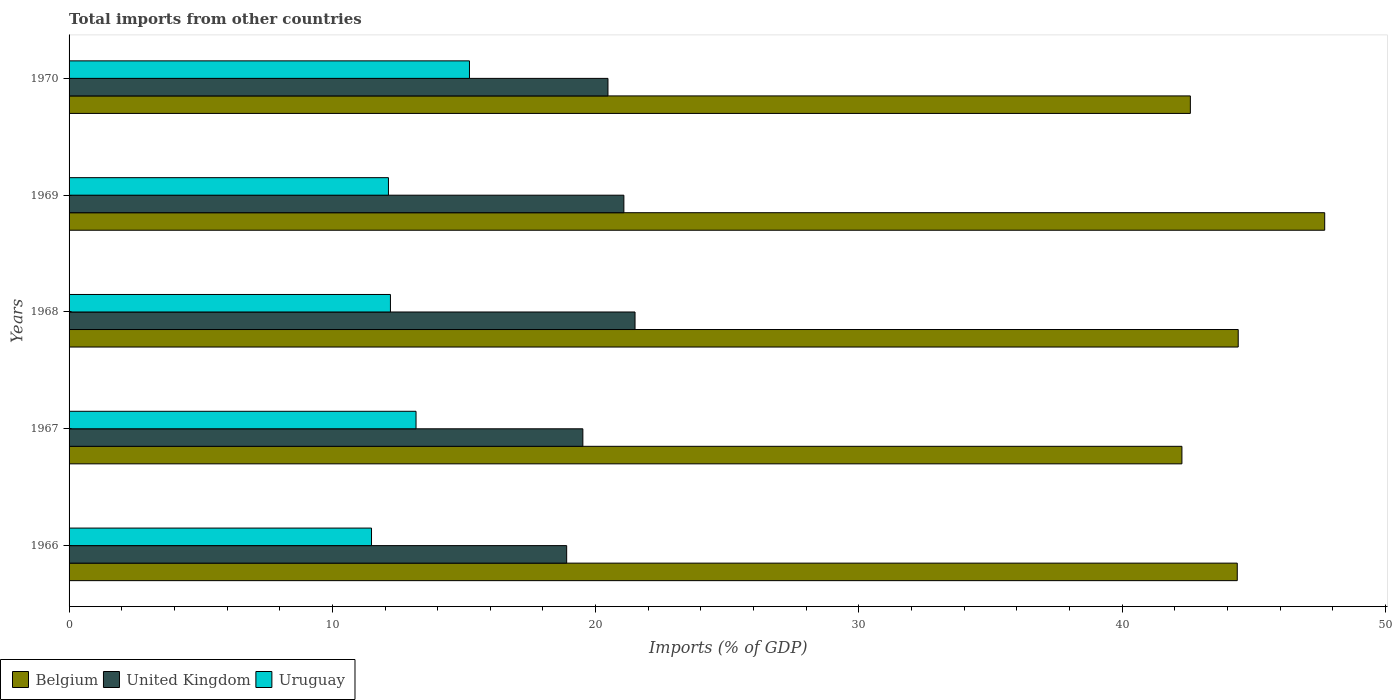How many different coloured bars are there?
Ensure brevity in your answer.  3. How many bars are there on the 2nd tick from the top?
Provide a succinct answer. 3. How many bars are there on the 5th tick from the bottom?
Your answer should be compact. 3. What is the label of the 5th group of bars from the top?
Offer a terse response. 1966. What is the total imports in United Kingdom in 1966?
Ensure brevity in your answer.  18.9. Across all years, what is the maximum total imports in Uruguay?
Offer a very short reply. 15.21. Across all years, what is the minimum total imports in Uruguay?
Your answer should be compact. 11.49. In which year was the total imports in Belgium maximum?
Offer a very short reply. 1969. In which year was the total imports in United Kingdom minimum?
Offer a very short reply. 1966. What is the total total imports in United Kingdom in the graph?
Keep it short and to the point. 101.45. What is the difference between the total imports in Belgium in 1966 and that in 1969?
Keep it short and to the point. -3.32. What is the difference between the total imports in United Kingdom in 1966 and the total imports in Uruguay in 1967?
Provide a short and direct response. 5.72. What is the average total imports in Uruguay per year?
Ensure brevity in your answer.  12.84. In the year 1968, what is the difference between the total imports in Belgium and total imports in Uruguay?
Your response must be concise. 32.2. In how many years, is the total imports in United Kingdom greater than 12 %?
Provide a succinct answer. 5. What is the ratio of the total imports in Uruguay in 1966 to that in 1967?
Keep it short and to the point. 0.87. Is the difference between the total imports in Belgium in 1969 and 1970 greater than the difference between the total imports in Uruguay in 1969 and 1970?
Offer a very short reply. Yes. What is the difference between the highest and the second highest total imports in Belgium?
Provide a short and direct response. 3.29. What is the difference between the highest and the lowest total imports in United Kingdom?
Offer a terse response. 2.6. What does the 2nd bar from the bottom in 1967 represents?
Offer a very short reply. United Kingdom. Is it the case that in every year, the sum of the total imports in Belgium and total imports in Uruguay is greater than the total imports in United Kingdom?
Provide a short and direct response. Yes. How many bars are there?
Your response must be concise. 15. How many years are there in the graph?
Your response must be concise. 5. Are the values on the major ticks of X-axis written in scientific E-notation?
Provide a short and direct response. No. Where does the legend appear in the graph?
Provide a short and direct response. Bottom left. How many legend labels are there?
Make the answer very short. 3. How are the legend labels stacked?
Provide a short and direct response. Horizontal. What is the title of the graph?
Offer a very short reply. Total imports from other countries. Does "Honduras" appear as one of the legend labels in the graph?
Your answer should be very brief. No. What is the label or title of the X-axis?
Offer a very short reply. Imports (% of GDP). What is the Imports (% of GDP) of Belgium in 1966?
Give a very brief answer. 44.37. What is the Imports (% of GDP) of United Kingdom in 1966?
Provide a succinct answer. 18.9. What is the Imports (% of GDP) of Uruguay in 1966?
Give a very brief answer. 11.49. What is the Imports (% of GDP) of Belgium in 1967?
Make the answer very short. 42.27. What is the Imports (% of GDP) in United Kingdom in 1967?
Your answer should be very brief. 19.51. What is the Imports (% of GDP) in Uruguay in 1967?
Offer a very short reply. 13.18. What is the Imports (% of GDP) in Belgium in 1968?
Offer a very short reply. 44.41. What is the Imports (% of GDP) in United Kingdom in 1968?
Offer a terse response. 21.5. What is the Imports (% of GDP) of Uruguay in 1968?
Offer a very short reply. 12.21. What is the Imports (% of GDP) in Belgium in 1969?
Your answer should be very brief. 47.69. What is the Imports (% of GDP) in United Kingdom in 1969?
Your answer should be very brief. 21.07. What is the Imports (% of GDP) of Uruguay in 1969?
Ensure brevity in your answer.  12.13. What is the Imports (% of GDP) of Belgium in 1970?
Offer a terse response. 42.59. What is the Imports (% of GDP) in United Kingdom in 1970?
Keep it short and to the point. 20.47. What is the Imports (% of GDP) of Uruguay in 1970?
Make the answer very short. 15.21. Across all years, what is the maximum Imports (% of GDP) in Belgium?
Offer a very short reply. 47.69. Across all years, what is the maximum Imports (% of GDP) in United Kingdom?
Keep it short and to the point. 21.5. Across all years, what is the maximum Imports (% of GDP) in Uruguay?
Keep it short and to the point. 15.21. Across all years, what is the minimum Imports (% of GDP) of Belgium?
Make the answer very short. 42.27. Across all years, what is the minimum Imports (% of GDP) in United Kingdom?
Keep it short and to the point. 18.9. Across all years, what is the minimum Imports (% of GDP) in Uruguay?
Provide a short and direct response. 11.49. What is the total Imports (% of GDP) in Belgium in the graph?
Offer a very short reply. 221.32. What is the total Imports (% of GDP) of United Kingdom in the graph?
Your answer should be very brief. 101.45. What is the total Imports (% of GDP) in Uruguay in the graph?
Give a very brief answer. 64.21. What is the difference between the Imports (% of GDP) of Belgium in 1966 and that in 1967?
Your answer should be compact. 2.1. What is the difference between the Imports (% of GDP) in United Kingdom in 1966 and that in 1967?
Keep it short and to the point. -0.61. What is the difference between the Imports (% of GDP) in Uruguay in 1966 and that in 1967?
Provide a short and direct response. -1.69. What is the difference between the Imports (% of GDP) of Belgium in 1966 and that in 1968?
Your response must be concise. -0.04. What is the difference between the Imports (% of GDP) of United Kingdom in 1966 and that in 1968?
Offer a terse response. -2.6. What is the difference between the Imports (% of GDP) in Uruguay in 1966 and that in 1968?
Provide a succinct answer. -0.72. What is the difference between the Imports (% of GDP) in Belgium in 1966 and that in 1969?
Make the answer very short. -3.32. What is the difference between the Imports (% of GDP) in United Kingdom in 1966 and that in 1969?
Offer a terse response. -2.17. What is the difference between the Imports (% of GDP) of Uruguay in 1966 and that in 1969?
Provide a short and direct response. -0.64. What is the difference between the Imports (% of GDP) in Belgium in 1966 and that in 1970?
Your response must be concise. 1.78. What is the difference between the Imports (% of GDP) in United Kingdom in 1966 and that in 1970?
Offer a very short reply. -1.57. What is the difference between the Imports (% of GDP) in Uruguay in 1966 and that in 1970?
Your response must be concise. -3.72. What is the difference between the Imports (% of GDP) in Belgium in 1967 and that in 1968?
Ensure brevity in your answer.  -2.14. What is the difference between the Imports (% of GDP) of United Kingdom in 1967 and that in 1968?
Provide a short and direct response. -1.98. What is the difference between the Imports (% of GDP) in Uruguay in 1967 and that in 1968?
Your answer should be very brief. 0.97. What is the difference between the Imports (% of GDP) of Belgium in 1967 and that in 1969?
Give a very brief answer. -5.42. What is the difference between the Imports (% of GDP) in United Kingdom in 1967 and that in 1969?
Ensure brevity in your answer.  -1.56. What is the difference between the Imports (% of GDP) in Uruguay in 1967 and that in 1969?
Your answer should be compact. 1.05. What is the difference between the Imports (% of GDP) of Belgium in 1967 and that in 1970?
Your answer should be compact. -0.32. What is the difference between the Imports (% of GDP) in United Kingdom in 1967 and that in 1970?
Your response must be concise. -0.95. What is the difference between the Imports (% of GDP) in Uruguay in 1967 and that in 1970?
Your answer should be very brief. -2.03. What is the difference between the Imports (% of GDP) in Belgium in 1968 and that in 1969?
Provide a short and direct response. -3.29. What is the difference between the Imports (% of GDP) in United Kingdom in 1968 and that in 1969?
Give a very brief answer. 0.42. What is the difference between the Imports (% of GDP) of Uruguay in 1968 and that in 1969?
Your answer should be compact. 0.08. What is the difference between the Imports (% of GDP) of Belgium in 1968 and that in 1970?
Your answer should be very brief. 1.82. What is the difference between the Imports (% of GDP) of United Kingdom in 1968 and that in 1970?
Make the answer very short. 1.03. What is the difference between the Imports (% of GDP) of Uruguay in 1968 and that in 1970?
Your response must be concise. -3. What is the difference between the Imports (% of GDP) of Belgium in 1969 and that in 1970?
Give a very brief answer. 5.1. What is the difference between the Imports (% of GDP) of United Kingdom in 1969 and that in 1970?
Your answer should be compact. 0.6. What is the difference between the Imports (% of GDP) in Uruguay in 1969 and that in 1970?
Provide a short and direct response. -3.08. What is the difference between the Imports (% of GDP) in Belgium in 1966 and the Imports (% of GDP) in United Kingdom in 1967?
Offer a terse response. 24.86. What is the difference between the Imports (% of GDP) of Belgium in 1966 and the Imports (% of GDP) of Uruguay in 1967?
Your response must be concise. 31.19. What is the difference between the Imports (% of GDP) of United Kingdom in 1966 and the Imports (% of GDP) of Uruguay in 1967?
Keep it short and to the point. 5.72. What is the difference between the Imports (% of GDP) in Belgium in 1966 and the Imports (% of GDP) in United Kingdom in 1968?
Give a very brief answer. 22.87. What is the difference between the Imports (% of GDP) in Belgium in 1966 and the Imports (% of GDP) in Uruguay in 1968?
Your answer should be very brief. 32.16. What is the difference between the Imports (% of GDP) in United Kingdom in 1966 and the Imports (% of GDP) in Uruguay in 1968?
Provide a short and direct response. 6.69. What is the difference between the Imports (% of GDP) of Belgium in 1966 and the Imports (% of GDP) of United Kingdom in 1969?
Give a very brief answer. 23.3. What is the difference between the Imports (% of GDP) in Belgium in 1966 and the Imports (% of GDP) in Uruguay in 1969?
Keep it short and to the point. 32.24. What is the difference between the Imports (% of GDP) in United Kingdom in 1966 and the Imports (% of GDP) in Uruguay in 1969?
Ensure brevity in your answer.  6.77. What is the difference between the Imports (% of GDP) of Belgium in 1966 and the Imports (% of GDP) of United Kingdom in 1970?
Offer a terse response. 23.9. What is the difference between the Imports (% of GDP) of Belgium in 1966 and the Imports (% of GDP) of Uruguay in 1970?
Give a very brief answer. 29.16. What is the difference between the Imports (% of GDP) of United Kingdom in 1966 and the Imports (% of GDP) of Uruguay in 1970?
Offer a terse response. 3.69. What is the difference between the Imports (% of GDP) of Belgium in 1967 and the Imports (% of GDP) of United Kingdom in 1968?
Ensure brevity in your answer.  20.77. What is the difference between the Imports (% of GDP) of Belgium in 1967 and the Imports (% of GDP) of Uruguay in 1968?
Your answer should be very brief. 30.06. What is the difference between the Imports (% of GDP) in United Kingdom in 1967 and the Imports (% of GDP) in Uruguay in 1968?
Ensure brevity in your answer.  7.31. What is the difference between the Imports (% of GDP) in Belgium in 1967 and the Imports (% of GDP) in United Kingdom in 1969?
Offer a terse response. 21.2. What is the difference between the Imports (% of GDP) in Belgium in 1967 and the Imports (% of GDP) in Uruguay in 1969?
Offer a very short reply. 30.14. What is the difference between the Imports (% of GDP) in United Kingdom in 1967 and the Imports (% of GDP) in Uruguay in 1969?
Offer a terse response. 7.38. What is the difference between the Imports (% of GDP) in Belgium in 1967 and the Imports (% of GDP) in United Kingdom in 1970?
Provide a short and direct response. 21.8. What is the difference between the Imports (% of GDP) in Belgium in 1967 and the Imports (% of GDP) in Uruguay in 1970?
Give a very brief answer. 27.06. What is the difference between the Imports (% of GDP) of United Kingdom in 1967 and the Imports (% of GDP) of Uruguay in 1970?
Make the answer very short. 4.31. What is the difference between the Imports (% of GDP) of Belgium in 1968 and the Imports (% of GDP) of United Kingdom in 1969?
Provide a short and direct response. 23.33. What is the difference between the Imports (% of GDP) of Belgium in 1968 and the Imports (% of GDP) of Uruguay in 1969?
Your response must be concise. 32.28. What is the difference between the Imports (% of GDP) of United Kingdom in 1968 and the Imports (% of GDP) of Uruguay in 1969?
Keep it short and to the point. 9.37. What is the difference between the Imports (% of GDP) of Belgium in 1968 and the Imports (% of GDP) of United Kingdom in 1970?
Ensure brevity in your answer.  23.94. What is the difference between the Imports (% of GDP) of Belgium in 1968 and the Imports (% of GDP) of Uruguay in 1970?
Your response must be concise. 29.2. What is the difference between the Imports (% of GDP) of United Kingdom in 1968 and the Imports (% of GDP) of Uruguay in 1970?
Keep it short and to the point. 6.29. What is the difference between the Imports (% of GDP) in Belgium in 1969 and the Imports (% of GDP) in United Kingdom in 1970?
Ensure brevity in your answer.  27.22. What is the difference between the Imports (% of GDP) in Belgium in 1969 and the Imports (% of GDP) in Uruguay in 1970?
Provide a short and direct response. 32.48. What is the difference between the Imports (% of GDP) of United Kingdom in 1969 and the Imports (% of GDP) of Uruguay in 1970?
Ensure brevity in your answer.  5.86. What is the average Imports (% of GDP) in Belgium per year?
Ensure brevity in your answer.  44.26. What is the average Imports (% of GDP) of United Kingdom per year?
Keep it short and to the point. 20.29. What is the average Imports (% of GDP) of Uruguay per year?
Your answer should be very brief. 12.84. In the year 1966, what is the difference between the Imports (% of GDP) of Belgium and Imports (% of GDP) of United Kingdom?
Offer a very short reply. 25.47. In the year 1966, what is the difference between the Imports (% of GDP) of Belgium and Imports (% of GDP) of Uruguay?
Make the answer very short. 32.88. In the year 1966, what is the difference between the Imports (% of GDP) of United Kingdom and Imports (% of GDP) of Uruguay?
Make the answer very short. 7.41. In the year 1967, what is the difference between the Imports (% of GDP) in Belgium and Imports (% of GDP) in United Kingdom?
Ensure brevity in your answer.  22.75. In the year 1967, what is the difference between the Imports (% of GDP) of Belgium and Imports (% of GDP) of Uruguay?
Provide a succinct answer. 29.09. In the year 1967, what is the difference between the Imports (% of GDP) of United Kingdom and Imports (% of GDP) of Uruguay?
Make the answer very short. 6.34. In the year 1968, what is the difference between the Imports (% of GDP) in Belgium and Imports (% of GDP) in United Kingdom?
Make the answer very short. 22.91. In the year 1968, what is the difference between the Imports (% of GDP) in Belgium and Imports (% of GDP) in Uruguay?
Provide a short and direct response. 32.2. In the year 1968, what is the difference between the Imports (% of GDP) in United Kingdom and Imports (% of GDP) in Uruguay?
Your answer should be compact. 9.29. In the year 1969, what is the difference between the Imports (% of GDP) in Belgium and Imports (% of GDP) in United Kingdom?
Offer a very short reply. 26.62. In the year 1969, what is the difference between the Imports (% of GDP) in Belgium and Imports (% of GDP) in Uruguay?
Provide a short and direct response. 35.56. In the year 1969, what is the difference between the Imports (% of GDP) of United Kingdom and Imports (% of GDP) of Uruguay?
Your response must be concise. 8.94. In the year 1970, what is the difference between the Imports (% of GDP) in Belgium and Imports (% of GDP) in United Kingdom?
Your answer should be very brief. 22.12. In the year 1970, what is the difference between the Imports (% of GDP) of Belgium and Imports (% of GDP) of Uruguay?
Make the answer very short. 27.38. In the year 1970, what is the difference between the Imports (% of GDP) in United Kingdom and Imports (% of GDP) in Uruguay?
Your answer should be very brief. 5.26. What is the ratio of the Imports (% of GDP) in Belgium in 1966 to that in 1967?
Your answer should be compact. 1.05. What is the ratio of the Imports (% of GDP) in United Kingdom in 1966 to that in 1967?
Offer a very short reply. 0.97. What is the ratio of the Imports (% of GDP) in Uruguay in 1966 to that in 1967?
Provide a short and direct response. 0.87. What is the ratio of the Imports (% of GDP) of Belgium in 1966 to that in 1968?
Give a very brief answer. 1. What is the ratio of the Imports (% of GDP) of United Kingdom in 1966 to that in 1968?
Offer a terse response. 0.88. What is the ratio of the Imports (% of GDP) in Uruguay in 1966 to that in 1968?
Your answer should be compact. 0.94. What is the ratio of the Imports (% of GDP) in Belgium in 1966 to that in 1969?
Offer a very short reply. 0.93. What is the ratio of the Imports (% of GDP) in United Kingdom in 1966 to that in 1969?
Ensure brevity in your answer.  0.9. What is the ratio of the Imports (% of GDP) of Uruguay in 1966 to that in 1969?
Your answer should be compact. 0.95. What is the ratio of the Imports (% of GDP) of Belgium in 1966 to that in 1970?
Keep it short and to the point. 1.04. What is the ratio of the Imports (% of GDP) of United Kingdom in 1966 to that in 1970?
Your response must be concise. 0.92. What is the ratio of the Imports (% of GDP) of Uruguay in 1966 to that in 1970?
Your answer should be very brief. 0.76. What is the ratio of the Imports (% of GDP) in Belgium in 1967 to that in 1968?
Give a very brief answer. 0.95. What is the ratio of the Imports (% of GDP) in United Kingdom in 1967 to that in 1968?
Your response must be concise. 0.91. What is the ratio of the Imports (% of GDP) in Uruguay in 1967 to that in 1968?
Give a very brief answer. 1.08. What is the ratio of the Imports (% of GDP) of Belgium in 1967 to that in 1969?
Your response must be concise. 0.89. What is the ratio of the Imports (% of GDP) in United Kingdom in 1967 to that in 1969?
Your response must be concise. 0.93. What is the ratio of the Imports (% of GDP) of Uruguay in 1967 to that in 1969?
Make the answer very short. 1.09. What is the ratio of the Imports (% of GDP) of Belgium in 1967 to that in 1970?
Your answer should be very brief. 0.99. What is the ratio of the Imports (% of GDP) in United Kingdom in 1967 to that in 1970?
Offer a terse response. 0.95. What is the ratio of the Imports (% of GDP) in Uruguay in 1967 to that in 1970?
Your response must be concise. 0.87. What is the ratio of the Imports (% of GDP) in Belgium in 1968 to that in 1969?
Offer a very short reply. 0.93. What is the ratio of the Imports (% of GDP) of United Kingdom in 1968 to that in 1969?
Offer a very short reply. 1.02. What is the ratio of the Imports (% of GDP) in Belgium in 1968 to that in 1970?
Ensure brevity in your answer.  1.04. What is the ratio of the Imports (% of GDP) of United Kingdom in 1968 to that in 1970?
Provide a succinct answer. 1.05. What is the ratio of the Imports (% of GDP) in Uruguay in 1968 to that in 1970?
Ensure brevity in your answer.  0.8. What is the ratio of the Imports (% of GDP) in Belgium in 1969 to that in 1970?
Make the answer very short. 1.12. What is the ratio of the Imports (% of GDP) in United Kingdom in 1969 to that in 1970?
Your answer should be very brief. 1.03. What is the ratio of the Imports (% of GDP) in Uruguay in 1969 to that in 1970?
Offer a very short reply. 0.8. What is the difference between the highest and the second highest Imports (% of GDP) of Belgium?
Make the answer very short. 3.29. What is the difference between the highest and the second highest Imports (% of GDP) in United Kingdom?
Give a very brief answer. 0.42. What is the difference between the highest and the second highest Imports (% of GDP) in Uruguay?
Your answer should be very brief. 2.03. What is the difference between the highest and the lowest Imports (% of GDP) of Belgium?
Make the answer very short. 5.42. What is the difference between the highest and the lowest Imports (% of GDP) in United Kingdom?
Make the answer very short. 2.6. What is the difference between the highest and the lowest Imports (% of GDP) in Uruguay?
Provide a succinct answer. 3.72. 